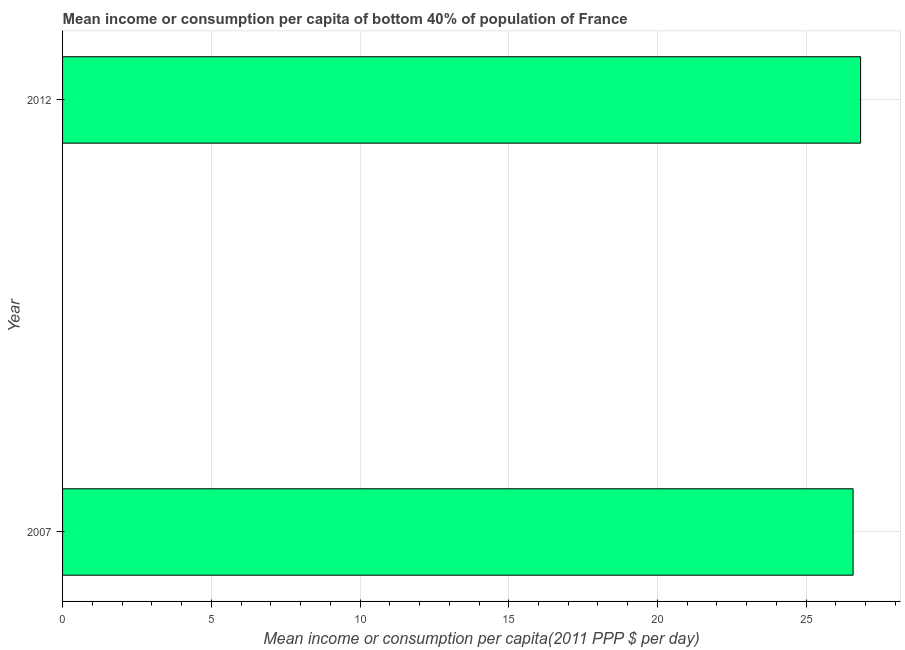Does the graph contain any zero values?
Your answer should be compact. No. What is the title of the graph?
Your answer should be very brief. Mean income or consumption per capita of bottom 40% of population of France. What is the label or title of the X-axis?
Your answer should be very brief. Mean income or consumption per capita(2011 PPP $ per day). What is the label or title of the Y-axis?
Your answer should be very brief. Year. What is the mean income or consumption in 2012?
Your response must be concise. 26.83. Across all years, what is the maximum mean income or consumption?
Offer a very short reply. 26.83. Across all years, what is the minimum mean income or consumption?
Provide a succinct answer. 26.58. In which year was the mean income or consumption minimum?
Keep it short and to the point. 2007. What is the sum of the mean income or consumption?
Offer a very short reply. 53.4. What is the difference between the mean income or consumption in 2007 and 2012?
Provide a succinct answer. -0.25. What is the average mean income or consumption per year?
Give a very brief answer. 26.7. What is the median mean income or consumption?
Offer a very short reply. 26.7. Do a majority of the years between 2007 and 2012 (inclusive) have mean income or consumption greater than 22 $?
Provide a short and direct response. Yes. In how many years, is the mean income or consumption greater than the average mean income or consumption taken over all years?
Your answer should be very brief. 1. How many bars are there?
Offer a terse response. 2. Are all the bars in the graph horizontal?
Provide a short and direct response. Yes. How many years are there in the graph?
Your response must be concise. 2. Are the values on the major ticks of X-axis written in scientific E-notation?
Keep it short and to the point. No. What is the Mean income or consumption per capita(2011 PPP $ per day) in 2007?
Your response must be concise. 26.58. What is the Mean income or consumption per capita(2011 PPP $ per day) in 2012?
Provide a short and direct response. 26.83. What is the difference between the Mean income or consumption per capita(2011 PPP $ per day) in 2007 and 2012?
Offer a very short reply. -0.25. What is the ratio of the Mean income or consumption per capita(2011 PPP $ per day) in 2007 to that in 2012?
Keep it short and to the point. 0.99. 